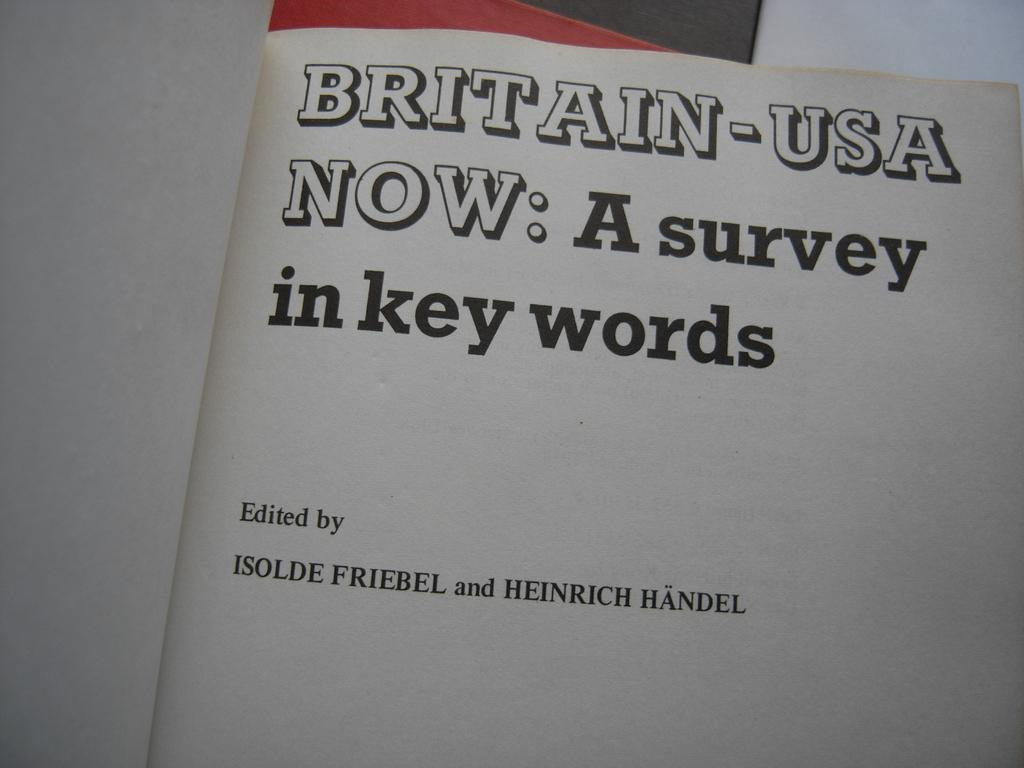Provide a one-sentence caption for the provided image. A book which is open to a page that says, "Britain-USA Now: A survey in key words". 